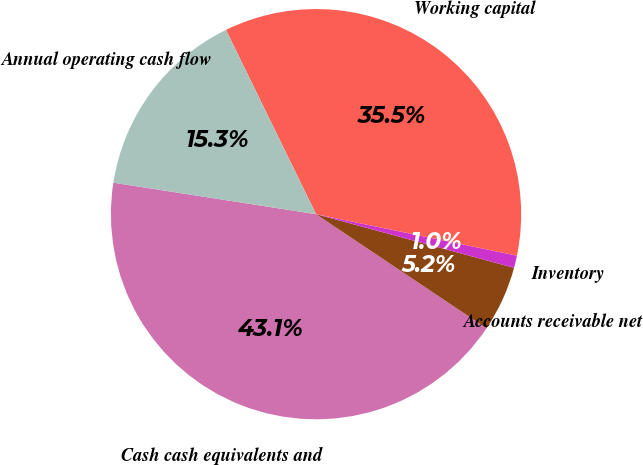<chart> <loc_0><loc_0><loc_500><loc_500><pie_chart><fcel>Cash cash equivalents and<fcel>Accounts receivable net<fcel>Inventory<fcel>Working capital<fcel>Annual operating cash flow<nl><fcel>43.06%<fcel>5.18%<fcel>0.97%<fcel>35.48%<fcel>15.31%<nl></chart> 